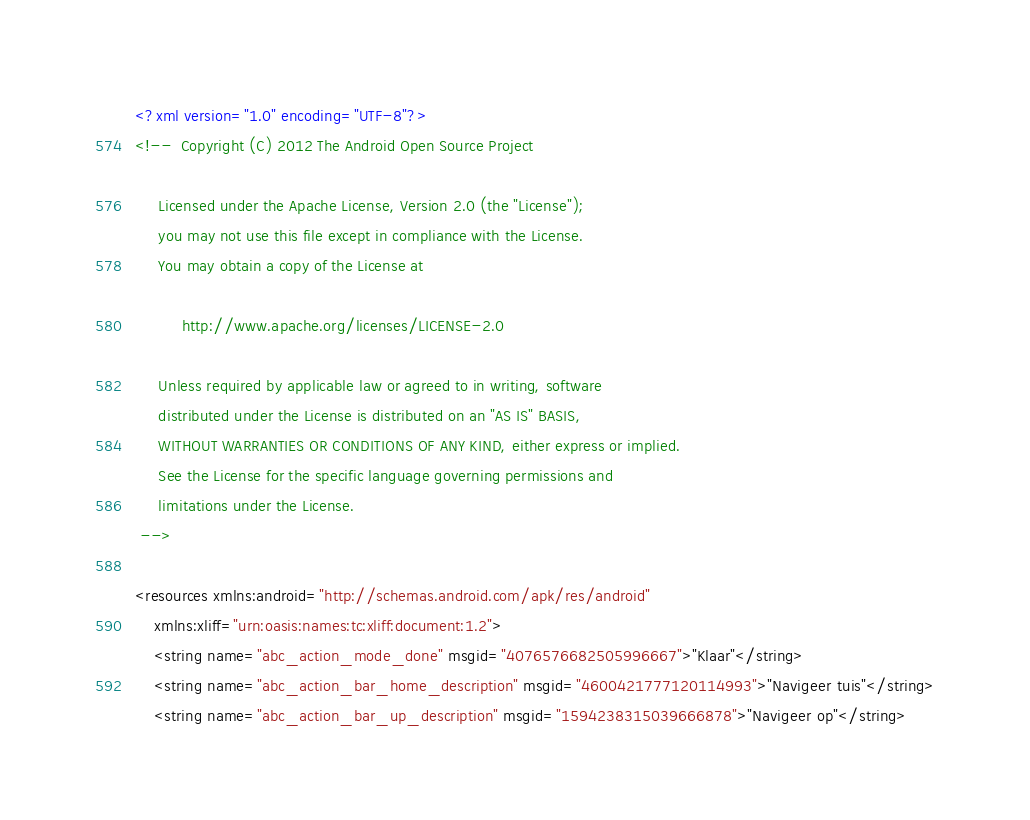<code> <loc_0><loc_0><loc_500><loc_500><_XML_><?xml version="1.0" encoding="UTF-8"?>
<!--  Copyright (C) 2012 The Android Open Source Project

     Licensed under the Apache License, Version 2.0 (the "License");
     you may not use this file except in compliance with the License.
     You may obtain a copy of the License at

          http://www.apache.org/licenses/LICENSE-2.0

     Unless required by applicable law or agreed to in writing, software
     distributed under the License is distributed on an "AS IS" BASIS,
     WITHOUT WARRANTIES OR CONDITIONS OF ANY KIND, either express or implied.
     See the License for the specific language governing permissions and
     limitations under the License.
 -->

<resources xmlns:android="http://schemas.android.com/apk/res/android"
    xmlns:xliff="urn:oasis:names:tc:xliff:document:1.2">
    <string name="abc_action_mode_done" msgid="4076576682505996667">"Klaar"</string>
    <string name="abc_action_bar_home_description" msgid="4600421777120114993">"Navigeer tuis"</string>
    <string name="abc_action_bar_up_description" msgid="1594238315039666878">"Navigeer op"</string></code> 